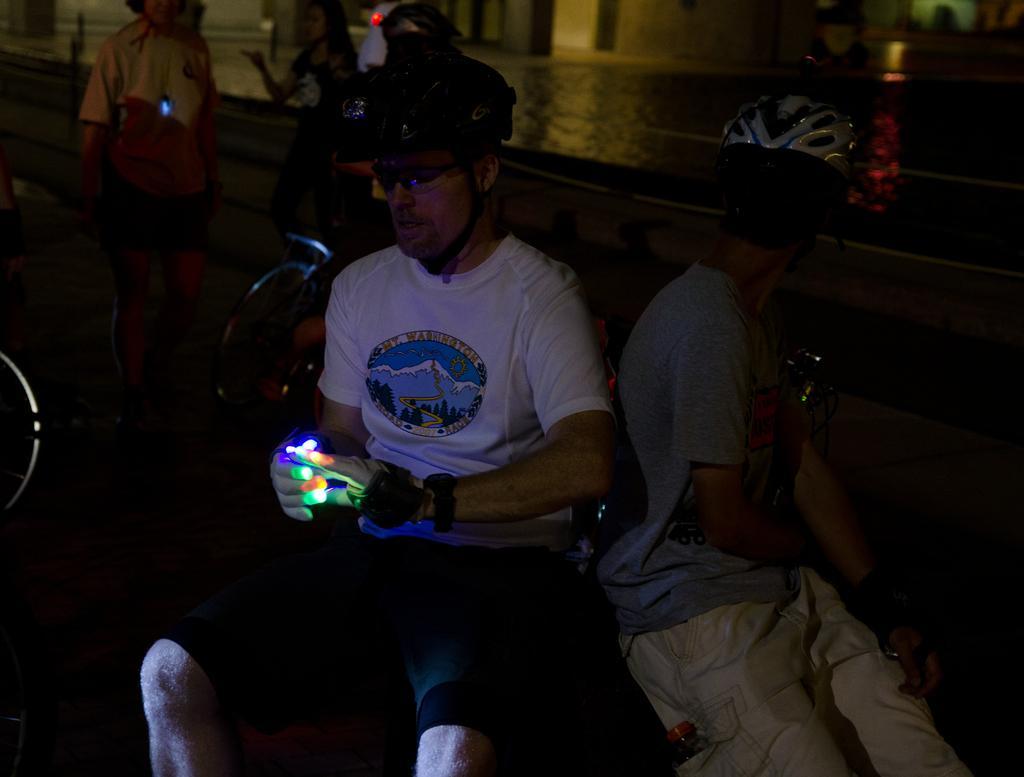How would you summarize this image in a sentence or two? In this image in the front there is a person sitting and holding an object wearing a black colour helmet. In the background there are persons and there is water. 